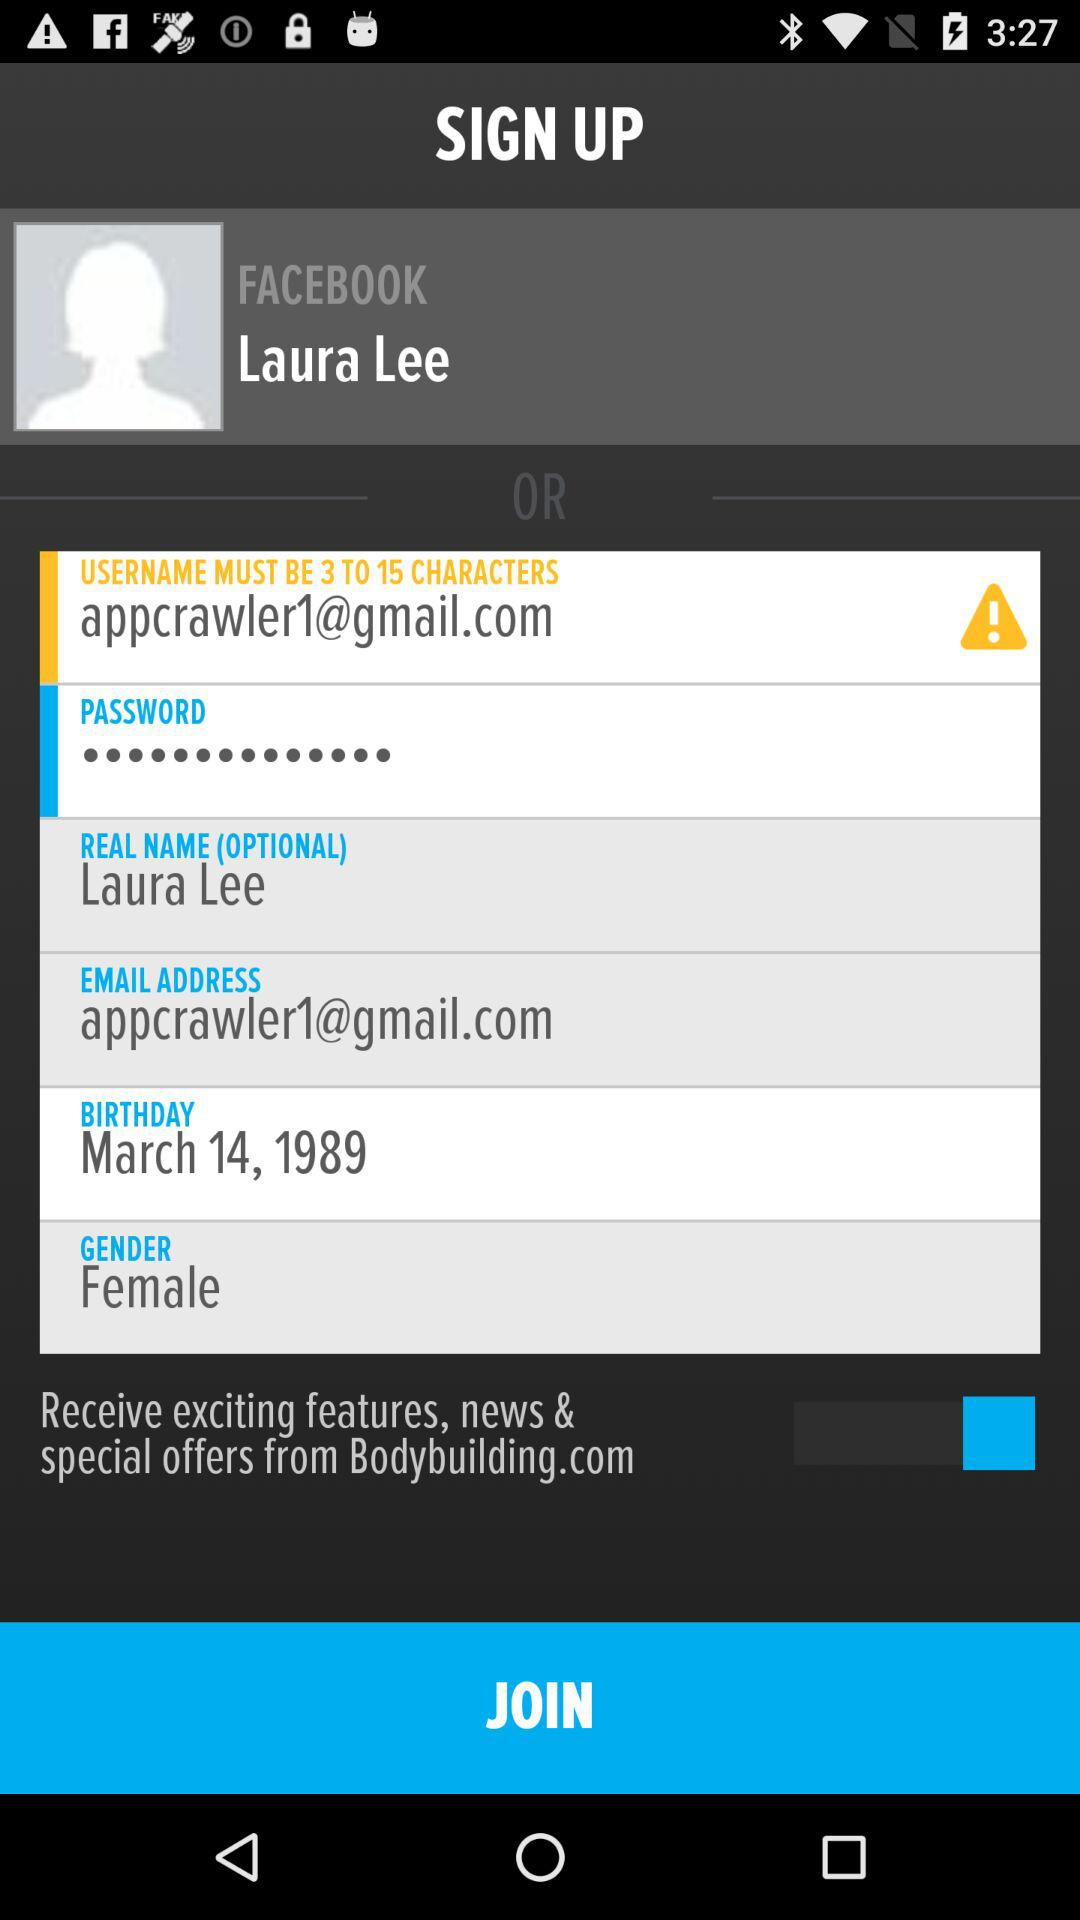What is the gender selected? The selected gender is female. 